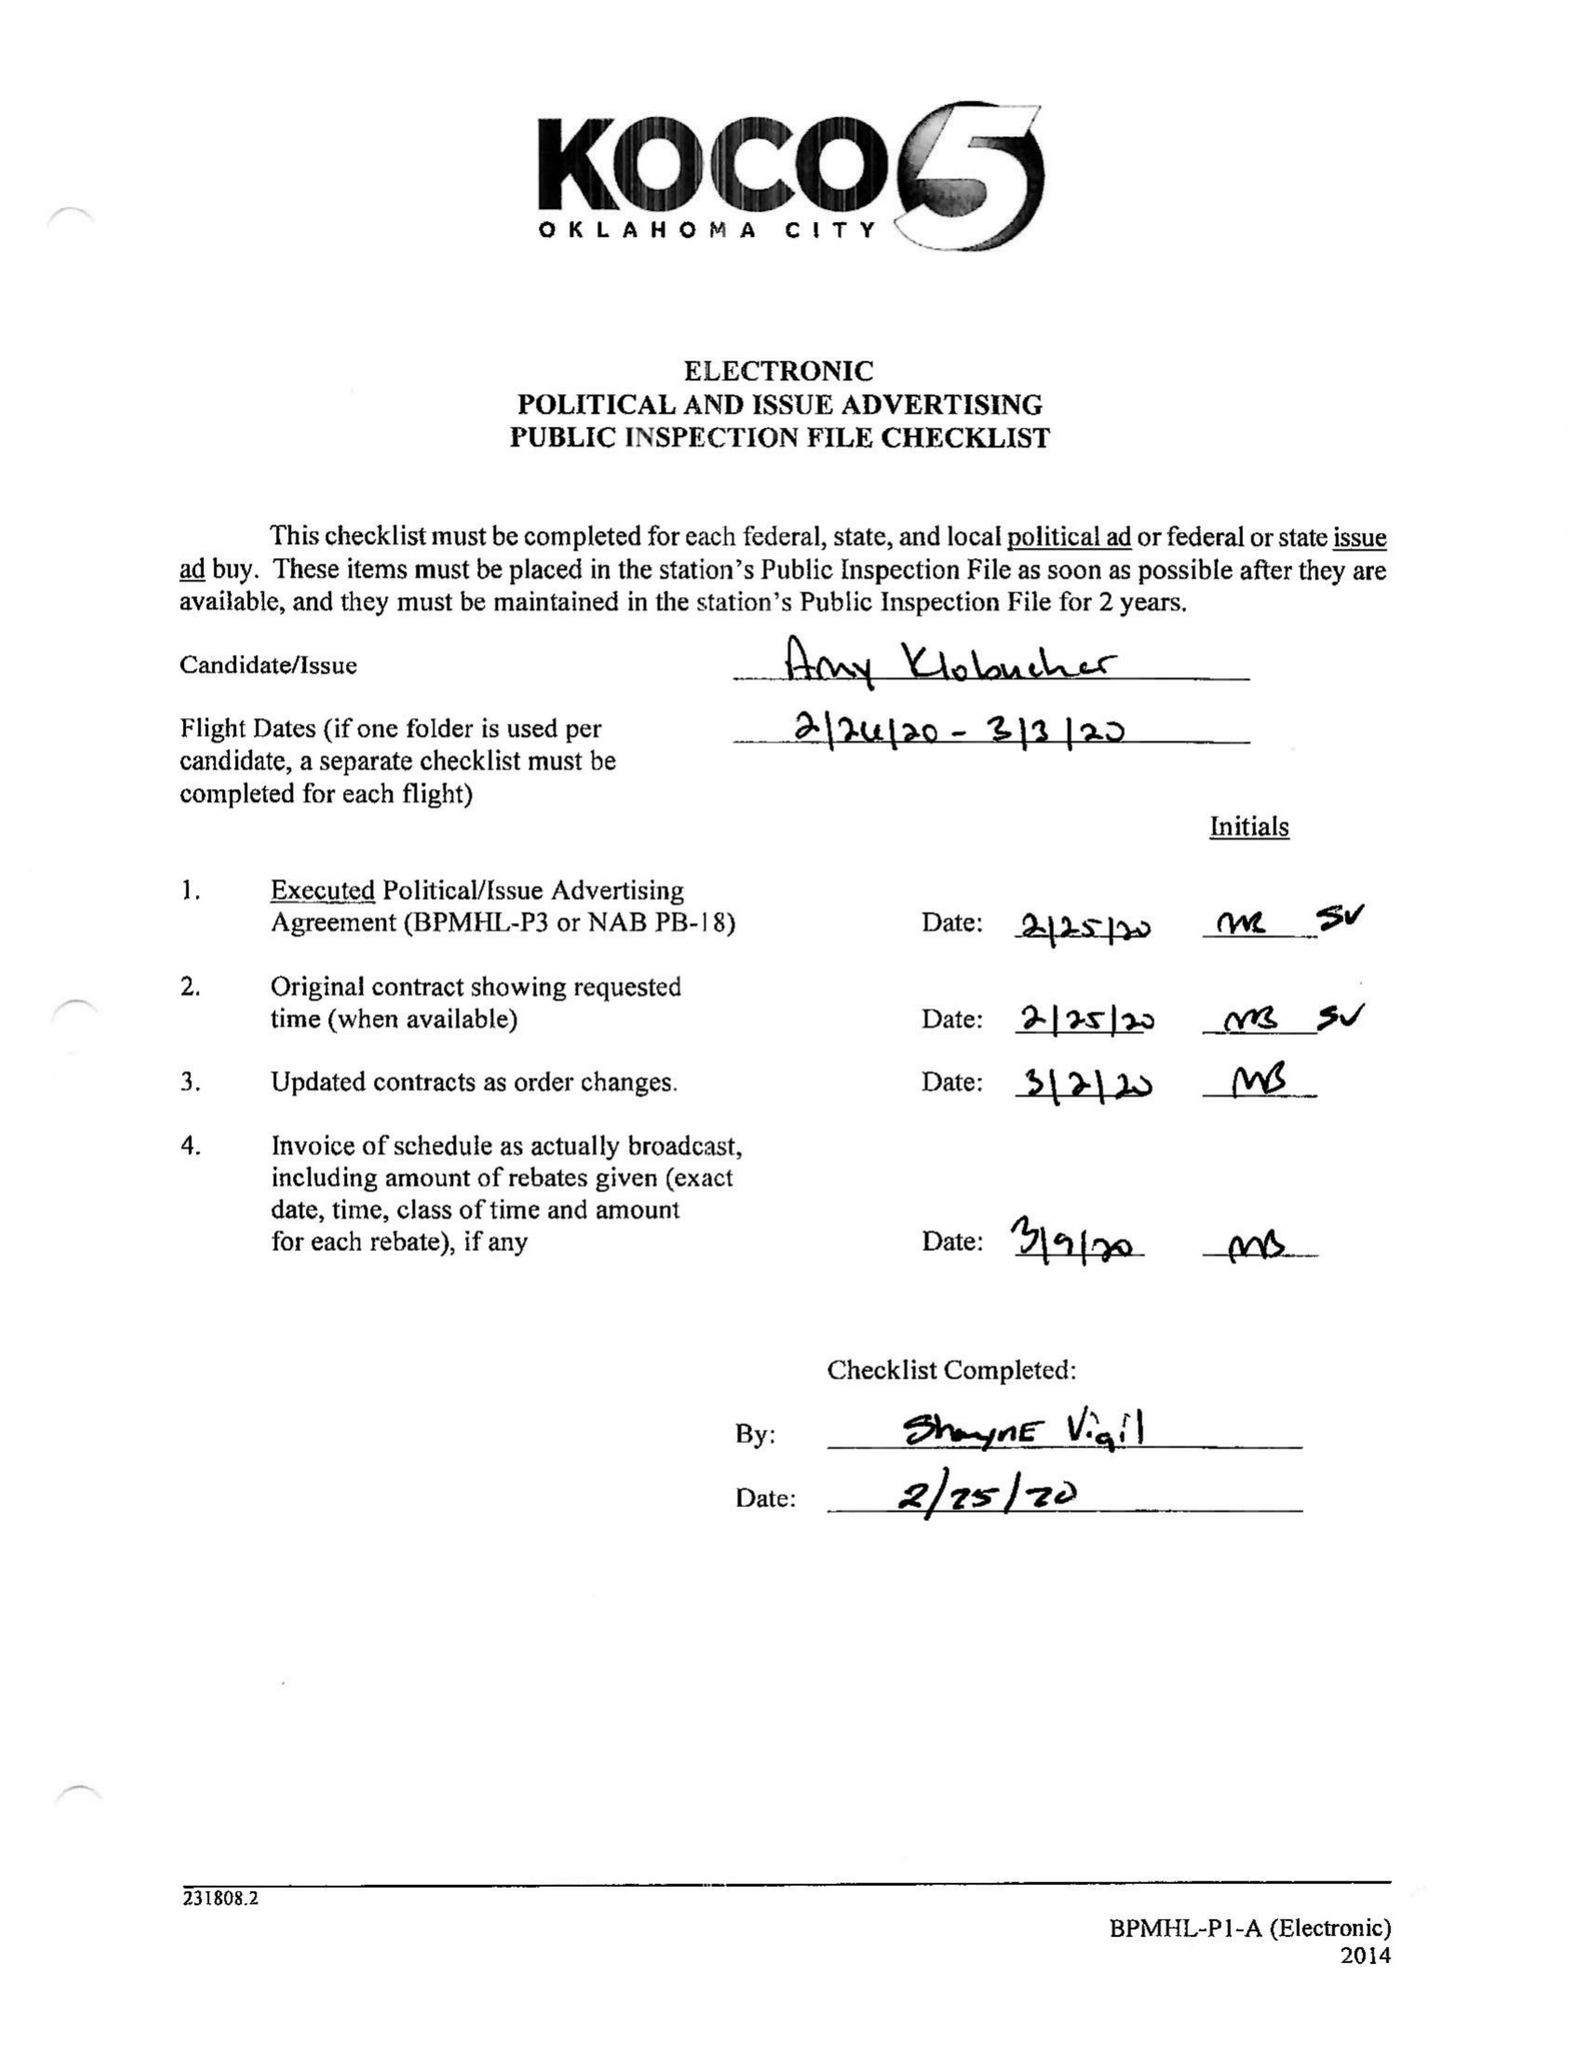What is the value for the advertiser?
Answer the question using a single word or phrase. KLOBUCHAR/D/PRESIDENT 